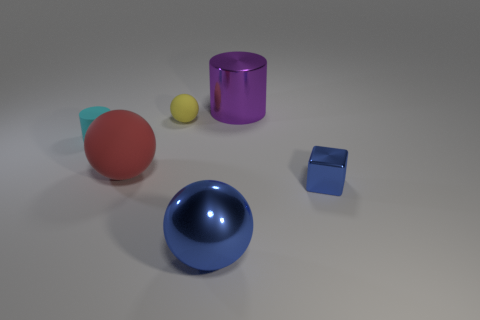What is the color of the big ball that is on the left side of the blue object on the left side of the tiny shiny object?
Your answer should be very brief. Red. How many small cyan metallic balls are there?
Provide a succinct answer. 0. What number of matte objects are either red objects or small red cylinders?
Provide a succinct answer. 1. How many small spheres have the same color as the block?
Offer a very short reply. 0. There is a object on the right side of the large object that is right of the blue metallic ball; what is its material?
Your answer should be compact. Metal. How big is the yellow matte object?
Your answer should be very brief. Small. What number of metal cylinders are the same size as the purple thing?
Give a very brief answer. 0. How many big purple things are the same shape as the cyan matte object?
Ensure brevity in your answer.  1. Are there the same number of yellow rubber things that are behind the large purple thing and small metallic cylinders?
Your answer should be compact. Yes. Is there any other thing that is the same size as the red sphere?
Your answer should be compact. Yes. 